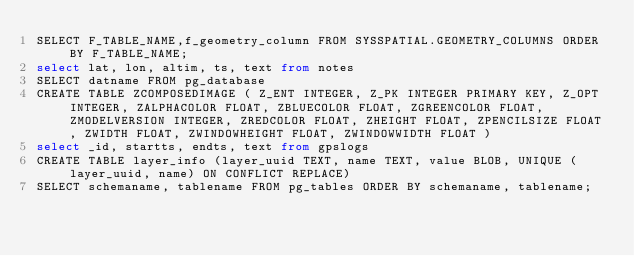<code> <loc_0><loc_0><loc_500><loc_500><_SQL_>SELECT F_TABLE_NAME,f_geometry_column FROM SYSSPATIAL.GEOMETRY_COLUMNS ORDER BY F_TABLE_NAME;
select lat, lon, altim, ts, text from notes
SELECT datname FROM pg_database
CREATE TABLE ZCOMPOSEDIMAGE ( Z_ENT INTEGER, Z_PK INTEGER PRIMARY KEY, Z_OPT INTEGER, ZALPHACOLOR FLOAT, ZBLUECOLOR FLOAT, ZGREENCOLOR FLOAT, ZMODELVERSION INTEGER, ZREDCOLOR FLOAT, ZHEIGHT FLOAT, ZPENCILSIZE FLOAT, ZWIDTH FLOAT, ZWINDOWHEIGHT FLOAT, ZWINDOWWIDTH FLOAT )
select _id, startts, endts, text from gpslogs
CREATE TABLE layer_info (layer_uuid TEXT, name TEXT, value BLOB, UNIQUE (layer_uuid, name) ON CONFLICT REPLACE)
SELECT schemaname, tablename FROM pg_tables ORDER BY schemaname, tablename;
</code> 